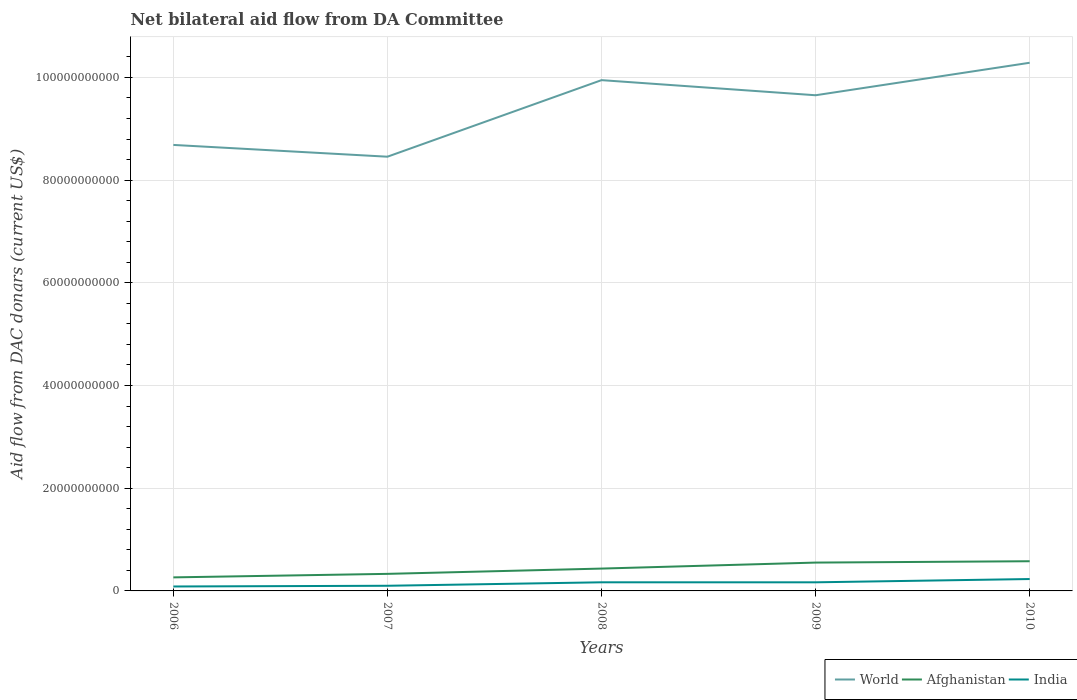Across all years, what is the maximum aid flow in in World?
Keep it short and to the point. 8.46e+1. What is the total aid flow in in World in the graph?
Your response must be concise. 2.29e+09. What is the difference between the highest and the second highest aid flow in in World?
Provide a short and direct response. 1.83e+1. What is the difference between the highest and the lowest aid flow in in World?
Your response must be concise. 3. Is the aid flow in in India strictly greater than the aid flow in in World over the years?
Your response must be concise. Yes. How many lines are there?
Give a very brief answer. 3. How many years are there in the graph?
Offer a terse response. 5. What is the difference between two consecutive major ticks on the Y-axis?
Provide a short and direct response. 2.00e+1. Does the graph contain any zero values?
Your response must be concise. No. Does the graph contain grids?
Provide a succinct answer. Yes. Where does the legend appear in the graph?
Offer a terse response. Bottom right. How many legend labels are there?
Offer a very short reply. 3. What is the title of the graph?
Make the answer very short. Net bilateral aid flow from DA Committee. What is the label or title of the Y-axis?
Your response must be concise. Aid flow from DAC donars (current US$). What is the Aid flow from DAC donars (current US$) in World in 2006?
Offer a terse response. 8.68e+1. What is the Aid flow from DAC donars (current US$) in Afghanistan in 2006?
Offer a very short reply. 2.64e+09. What is the Aid flow from DAC donars (current US$) in India in 2006?
Ensure brevity in your answer.  8.64e+08. What is the Aid flow from DAC donars (current US$) of World in 2007?
Offer a terse response. 8.46e+1. What is the Aid flow from DAC donars (current US$) in Afghanistan in 2007?
Offer a terse response. 3.32e+09. What is the Aid flow from DAC donars (current US$) of India in 2007?
Offer a terse response. 1.00e+09. What is the Aid flow from DAC donars (current US$) in World in 2008?
Your answer should be very brief. 9.95e+1. What is the Aid flow from DAC donars (current US$) of Afghanistan in 2008?
Make the answer very short. 4.35e+09. What is the Aid flow from DAC donars (current US$) in India in 2008?
Offer a terse response. 1.68e+09. What is the Aid flow from DAC donars (current US$) in World in 2009?
Provide a short and direct response. 9.65e+1. What is the Aid flow from DAC donars (current US$) of Afghanistan in 2009?
Your answer should be compact. 5.52e+09. What is the Aid flow from DAC donars (current US$) in India in 2009?
Give a very brief answer. 1.68e+09. What is the Aid flow from DAC donars (current US$) in World in 2010?
Keep it short and to the point. 1.03e+11. What is the Aid flow from DAC donars (current US$) of Afghanistan in 2010?
Give a very brief answer. 5.78e+09. What is the Aid flow from DAC donars (current US$) of India in 2010?
Your answer should be very brief. 2.31e+09. Across all years, what is the maximum Aid flow from DAC donars (current US$) of World?
Provide a succinct answer. 1.03e+11. Across all years, what is the maximum Aid flow from DAC donars (current US$) in Afghanistan?
Your answer should be compact. 5.78e+09. Across all years, what is the maximum Aid flow from DAC donars (current US$) in India?
Ensure brevity in your answer.  2.31e+09. Across all years, what is the minimum Aid flow from DAC donars (current US$) in World?
Offer a very short reply. 8.46e+1. Across all years, what is the minimum Aid flow from DAC donars (current US$) of Afghanistan?
Give a very brief answer. 2.64e+09. Across all years, what is the minimum Aid flow from DAC donars (current US$) in India?
Offer a terse response. 8.64e+08. What is the total Aid flow from DAC donars (current US$) in World in the graph?
Your answer should be very brief. 4.70e+11. What is the total Aid flow from DAC donars (current US$) of Afghanistan in the graph?
Offer a terse response. 2.16e+1. What is the total Aid flow from DAC donars (current US$) of India in the graph?
Provide a short and direct response. 7.54e+09. What is the difference between the Aid flow from DAC donars (current US$) of World in 2006 and that in 2007?
Keep it short and to the point. 2.29e+09. What is the difference between the Aid flow from DAC donars (current US$) in Afghanistan in 2006 and that in 2007?
Provide a succinct answer. -6.83e+08. What is the difference between the Aid flow from DAC donars (current US$) in India in 2006 and that in 2007?
Your answer should be compact. -1.40e+08. What is the difference between the Aid flow from DAC donars (current US$) in World in 2006 and that in 2008?
Keep it short and to the point. -1.26e+1. What is the difference between the Aid flow from DAC donars (current US$) of Afghanistan in 2006 and that in 2008?
Provide a short and direct response. -1.71e+09. What is the difference between the Aid flow from DAC donars (current US$) in India in 2006 and that in 2008?
Ensure brevity in your answer.  -8.15e+08. What is the difference between the Aid flow from DAC donars (current US$) of World in 2006 and that in 2009?
Your answer should be very brief. -9.67e+09. What is the difference between the Aid flow from DAC donars (current US$) in Afghanistan in 2006 and that in 2009?
Your response must be concise. -2.88e+09. What is the difference between the Aid flow from DAC donars (current US$) in India in 2006 and that in 2009?
Provide a succinct answer. -8.13e+08. What is the difference between the Aid flow from DAC donars (current US$) of World in 2006 and that in 2010?
Offer a very short reply. -1.60e+1. What is the difference between the Aid flow from DAC donars (current US$) of Afghanistan in 2006 and that in 2010?
Offer a terse response. -3.14e+09. What is the difference between the Aid flow from DAC donars (current US$) in India in 2006 and that in 2010?
Provide a short and direct response. -1.45e+09. What is the difference between the Aid flow from DAC donars (current US$) in World in 2007 and that in 2008?
Give a very brief answer. -1.49e+1. What is the difference between the Aid flow from DAC donars (current US$) of Afghanistan in 2007 and that in 2008?
Provide a short and direct response. -1.03e+09. What is the difference between the Aid flow from DAC donars (current US$) of India in 2007 and that in 2008?
Make the answer very short. -6.75e+08. What is the difference between the Aid flow from DAC donars (current US$) in World in 2007 and that in 2009?
Your answer should be very brief. -1.20e+1. What is the difference between the Aid flow from DAC donars (current US$) of Afghanistan in 2007 and that in 2009?
Your response must be concise. -2.20e+09. What is the difference between the Aid flow from DAC donars (current US$) of India in 2007 and that in 2009?
Ensure brevity in your answer.  -6.73e+08. What is the difference between the Aid flow from DAC donars (current US$) of World in 2007 and that in 2010?
Keep it short and to the point. -1.83e+1. What is the difference between the Aid flow from DAC donars (current US$) in Afghanistan in 2007 and that in 2010?
Give a very brief answer. -2.46e+09. What is the difference between the Aid flow from DAC donars (current US$) of India in 2007 and that in 2010?
Your response must be concise. -1.31e+09. What is the difference between the Aid flow from DAC donars (current US$) of World in 2008 and that in 2009?
Give a very brief answer. 2.94e+09. What is the difference between the Aid flow from DAC donars (current US$) in Afghanistan in 2008 and that in 2009?
Provide a succinct answer. -1.17e+09. What is the difference between the Aid flow from DAC donars (current US$) in India in 2008 and that in 2009?
Provide a short and direct response. 1.66e+06. What is the difference between the Aid flow from DAC donars (current US$) in World in 2008 and that in 2010?
Offer a very short reply. -3.38e+09. What is the difference between the Aid flow from DAC donars (current US$) of Afghanistan in 2008 and that in 2010?
Ensure brevity in your answer.  -1.43e+09. What is the difference between the Aid flow from DAC donars (current US$) of India in 2008 and that in 2010?
Ensure brevity in your answer.  -6.35e+08. What is the difference between the Aid flow from DAC donars (current US$) in World in 2009 and that in 2010?
Offer a terse response. -6.33e+09. What is the difference between the Aid flow from DAC donars (current US$) in Afghanistan in 2009 and that in 2010?
Provide a succinct answer. -2.60e+08. What is the difference between the Aid flow from DAC donars (current US$) of India in 2009 and that in 2010?
Make the answer very short. -6.37e+08. What is the difference between the Aid flow from DAC donars (current US$) of World in 2006 and the Aid flow from DAC donars (current US$) of Afghanistan in 2007?
Your response must be concise. 8.35e+1. What is the difference between the Aid flow from DAC donars (current US$) of World in 2006 and the Aid flow from DAC donars (current US$) of India in 2007?
Offer a very short reply. 8.58e+1. What is the difference between the Aid flow from DAC donars (current US$) in Afghanistan in 2006 and the Aid flow from DAC donars (current US$) in India in 2007?
Give a very brief answer. 1.63e+09. What is the difference between the Aid flow from DAC donars (current US$) of World in 2006 and the Aid flow from DAC donars (current US$) of Afghanistan in 2008?
Keep it short and to the point. 8.25e+1. What is the difference between the Aid flow from DAC donars (current US$) in World in 2006 and the Aid flow from DAC donars (current US$) in India in 2008?
Your answer should be compact. 8.52e+1. What is the difference between the Aid flow from DAC donars (current US$) of Afghanistan in 2006 and the Aid flow from DAC donars (current US$) of India in 2008?
Give a very brief answer. 9.60e+08. What is the difference between the Aid flow from DAC donars (current US$) in World in 2006 and the Aid flow from DAC donars (current US$) in Afghanistan in 2009?
Your answer should be compact. 8.13e+1. What is the difference between the Aid flow from DAC donars (current US$) of World in 2006 and the Aid flow from DAC donars (current US$) of India in 2009?
Provide a short and direct response. 8.52e+1. What is the difference between the Aid flow from DAC donars (current US$) of Afghanistan in 2006 and the Aid flow from DAC donars (current US$) of India in 2009?
Offer a very short reply. 9.61e+08. What is the difference between the Aid flow from DAC donars (current US$) of World in 2006 and the Aid flow from DAC donars (current US$) of Afghanistan in 2010?
Your answer should be compact. 8.11e+1. What is the difference between the Aid flow from DAC donars (current US$) in World in 2006 and the Aid flow from DAC donars (current US$) in India in 2010?
Provide a short and direct response. 8.45e+1. What is the difference between the Aid flow from DAC donars (current US$) in Afghanistan in 2006 and the Aid flow from DAC donars (current US$) in India in 2010?
Make the answer very short. 3.24e+08. What is the difference between the Aid flow from DAC donars (current US$) in World in 2007 and the Aid flow from DAC donars (current US$) in Afghanistan in 2008?
Make the answer very short. 8.02e+1. What is the difference between the Aid flow from DAC donars (current US$) in World in 2007 and the Aid flow from DAC donars (current US$) in India in 2008?
Provide a short and direct response. 8.29e+1. What is the difference between the Aid flow from DAC donars (current US$) of Afghanistan in 2007 and the Aid flow from DAC donars (current US$) of India in 2008?
Give a very brief answer. 1.64e+09. What is the difference between the Aid flow from DAC donars (current US$) of World in 2007 and the Aid flow from DAC donars (current US$) of Afghanistan in 2009?
Offer a very short reply. 7.90e+1. What is the difference between the Aid flow from DAC donars (current US$) in World in 2007 and the Aid flow from DAC donars (current US$) in India in 2009?
Offer a very short reply. 8.29e+1. What is the difference between the Aid flow from DAC donars (current US$) of Afghanistan in 2007 and the Aid flow from DAC donars (current US$) of India in 2009?
Your answer should be compact. 1.64e+09. What is the difference between the Aid flow from DAC donars (current US$) of World in 2007 and the Aid flow from DAC donars (current US$) of Afghanistan in 2010?
Your answer should be compact. 7.88e+1. What is the difference between the Aid flow from DAC donars (current US$) in World in 2007 and the Aid flow from DAC donars (current US$) in India in 2010?
Ensure brevity in your answer.  8.22e+1. What is the difference between the Aid flow from DAC donars (current US$) of Afghanistan in 2007 and the Aid flow from DAC donars (current US$) of India in 2010?
Offer a very short reply. 1.01e+09. What is the difference between the Aid flow from DAC donars (current US$) of World in 2008 and the Aid flow from DAC donars (current US$) of Afghanistan in 2009?
Provide a succinct answer. 9.39e+1. What is the difference between the Aid flow from DAC donars (current US$) of World in 2008 and the Aid flow from DAC donars (current US$) of India in 2009?
Your answer should be compact. 9.78e+1. What is the difference between the Aid flow from DAC donars (current US$) in Afghanistan in 2008 and the Aid flow from DAC donars (current US$) in India in 2009?
Offer a terse response. 2.67e+09. What is the difference between the Aid flow from DAC donars (current US$) in World in 2008 and the Aid flow from DAC donars (current US$) in Afghanistan in 2010?
Keep it short and to the point. 9.37e+1. What is the difference between the Aid flow from DAC donars (current US$) in World in 2008 and the Aid flow from DAC donars (current US$) in India in 2010?
Provide a succinct answer. 9.71e+1. What is the difference between the Aid flow from DAC donars (current US$) in Afghanistan in 2008 and the Aid flow from DAC donars (current US$) in India in 2010?
Keep it short and to the point. 2.04e+09. What is the difference between the Aid flow from DAC donars (current US$) of World in 2009 and the Aid flow from DAC donars (current US$) of Afghanistan in 2010?
Keep it short and to the point. 9.07e+1. What is the difference between the Aid flow from DAC donars (current US$) in World in 2009 and the Aid flow from DAC donars (current US$) in India in 2010?
Keep it short and to the point. 9.42e+1. What is the difference between the Aid flow from DAC donars (current US$) of Afghanistan in 2009 and the Aid flow from DAC donars (current US$) of India in 2010?
Ensure brevity in your answer.  3.21e+09. What is the average Aid flow from DAC donars (current US$) of World per year?
Provide a short and direct response. 9.40e+1. What is the average Aid flow from DAC donars (current US$) of Afghanistan per year?
Your answer should be compact. 4.32e+09. What is the average Aid flow from DAC donars (current US$) of India per year?
Provide a succinct answer. 1.51e+09. In the year 2006, what is the difference between the Aid flow from DAC donars (current US$) of World and Aid flow from DAC donars (current US$) of Afghanistan?
Offer a very short reply. 8.42e+1. In the year 2006, what is the difference between the Aid flow from DAC donars (current US$) in World and Aid flow from DAC donars (current US$) in India?
Your answer should be compact. 8.60e+1. In the year 2006, what is the difference between the Aid flow from DAC donars (current US$) in Afghanistan and Aid flow from DAC donars (current US$) in India?
Ensure brevity in your answer.  1.77e+09. In the year 2007, what is the difference between the Aid flow from DAC donars (current US$) of World and Aid flow from DAC donars (current US$) of Afghanistan?
Your answer should be very brief. 8.12e+1. In the year 2007, what is the difference between the Aid flow from DAC donars (current US$) in World and Aid flow from DAC donars (current US$) in India?
Provide a short and direct response. 8.36e+1. In the year 2007, what is the difference between the Aid flow from DAC donars (current US$) of Afghanistan and Aid flow from DAC donars (current US$) of India?
Give a very brief answer. 2.32e+09. In the year 2008, what is the difference between the Aid flow from DAC donars (current US$) of World and Aid flow from DAC donars (current US$) of Afghanistan?
Give a very brief answer. 9.51e+1. In the year 2008, what is the difference between the Aid flow from DAC donars (current US$) in World and Aid flow from DAC donars (current US$) in India?
Your answer should be very brief. 9.78e+1. In the year 2008, what is the difference between the Aid flow from DAC donars (current US$) in Afghanistan and Aid flow from DAC donars (current US$) in India?
Ensure brevity in your answer.  2.67e+09. In the year 2009, what is the difference between the Aid flow from DAC donars (current US$) in World and Aid flow from DAC donars (current US$) in Afghanistan?
Ensure brevity in your answer.  9.10e+1. In the year 2009, what is the difference between the Aid flow from DAC donars (current US$) of World and Aid flow from DAC donars (current US$) of India?
Provide a succinct answer. 9.48e+1. In the year 2009, what is the difference between the Aid flow from DAC donars (current US$) of Afghanistan and Aid flow from DAC donars (current US$) of India?
Give a very brief answer. 3.84e+09. In the year 2010, what is the difference between the Aid flow from DAC donars (current US$) in World and Aid flow from DAC donars (current US$) in Afghanistan?
Give a very brief answer. 9.71e+1. In the year 2010, what is the difference between the Aid flow from DAC donars (current US$) of World and Aid flow from DAC donars (current US$) of India?
Your answer should be very brief. 1.01e+11. In the year 2010, what is the difference between the Aid flow from DAC donars (current US$) of Afghanistan and Aid flow from DAC donars (current US$) of India?
Your response must be concise. 3.47e+09. What is the ratio of the Aid flow from DAC donars (current US$) in World in 2006 to that in 2007?
Offer a very short reply. 1.03. What is the ratio of the Aid flow from DAC donars (current US$) in Afghanistan in 2006 to that in 2007?
Keep it short and to the point. 0.79. What is the ratio of the Aid flow from DAC donars (current US$) of India in 2006 to that in 2007?
Make the answer very short. 0.86. What is the ratio of the Aid flow from DAC donars (current US$) of World in 2006 to that in 2008?
Offer a very short reply. 0.87. What is the ratio of the Aid flow from DAC donars (current US$) in Afghanistan in 2006 to that in 2008?
Your answer should be very brief. 0.61. What is the ratio of the Aid flow from DAC donars (current US$) in India in 2006 to that in 2008?
Your answer should be very brief. 0.51. What is the ratio of the Aid flow from DAC donars (current US$) of World in 2006 to that in 2009?
Offer a terse response. 0.9. What is the ratio of the Aid flow from DAC donars (current US$) in Afghanistan in 2006 to that in 2009?
Keep it short and to the point. 0.48. What is the ratio of the Aid flow from DAC donars (current US$) of India in 2006 to that in 2009?
Keep it short and to the point. 0.52. What is the ratio of the Aid flow from DAC donars (current US$) in World in 2006 to that in 2010?
Offer a very short reply. 0.84. What is the ratio of the Aid flow from DAC donars (current US$) of Afghanistan in 2006 to that in 2010?
Provide a succinct answer. 0.46. What is the ratio of the Aid flow from DAC donars (current US$) in India in 2006 to that in 2010?
Your answer should be compact. 0.37. What is the ratio of the Aid flow from DAC donars (current US$) of World in 2007 to that in 2008?
Your response must be concise. 0.85. What is the ratio of the Aid flow from DAC donars (current US$) of Afghanistan in 2007 to that in 2008?
Your answer should be compact. 0.76. What is the ratio of the Aid flow from DAC donars (current US$) in India in 2007 to that in 2008?
Provide a succinct answer. 0.6. What is the ratio of the Aid flow from DAC donars (current US$) of World in 2007 to that in 2009?
Provide a succinct answer. 0.88. What is the ratio of the Aid flow from DAC donars (current US$) in Afghanistan in 2007 to that in 2009?
Keep it short and to the point. 0.6. What is the ratio of the Aid flow from DAC donars (current US$) of India in 2007 to that in 2009?
Provide a succinct answer. 0.6. What is the ratio of the Aid flow from DAC donars (current US$) in World in 2007 to that in 2010?
Give a very brief answer. 0.82. What is the ratio of the Aid flow from DAC donars (current US$) in Afghanistan in 2007 to that in 2010?
Keep it short and to the point. 0.57. What is the ratio of the Aid flow from DAC donars (current US$) in India in 2007 to that in 2010?
Give a very brief answer. 0.43. What is the ratio of the Aid flow from DAC donars (current US$) of World in 2008 to that in 2009?
Your answer should be compact. 1.03. What is the ratio of the Aid flow from DAC donars (current US$) of Afghanistan in 2008 to that in 2009?
Offer a terse response. 0.79. What is the ratio of the Aid flow from DAC donars (current US$) in India in 2008 to that in 2009?
Ensure brevity in your answer.  1. What is the ratio of the Aid flow from DAC donars (current US$) of World in 2008 to that in 2010?
Your answer should be compact. 0.97. What is the ratio of the Aid flow from DAC donars (current US$) in Afghanistan in 2008 to that in 2010?
Keep it short and to the point. 0.75. What is the ratio of the Aid flow from DAC donars (current US$) of India in 2008 to that in 2010?
Offer a very short reply. 0.73. What is the ratio of the Aid flow from DAC donars (current US$) of World in 2009 to that in 2010?
Offer a terse response. 0.94. What is the ratio of the Aid flow from DAC donars (current US$) in Afghanistan in 2009 to that in 2010?
Ensure brevity in your answer.  0.95. What is the ratio of the Aid flow from DAC donars (current US$) in India in 2009 to that in 2010?
Provide a succinct answer. 0.72. What is the difference between the highest and the second highest Aid flow from DAC donars (current US$) of World?
Provide a succinct answer. 3.38e+09. What is the difference between the highest and the second highest Aid flow from DAC donars (current US$) of Afghanistan?
Your answer should be compact. 2.60e+08. What is the difference between the highest and the second highest Aid flow from DAC donars (current US$) of India?
Offer a terse response. 6.35e+08. What is the difference between the highest and the lowest Aid flow from DAC donars (current US$) of World?
Your response must be concise. 1.83e+1. What is the difference between the highest and the lowest Aid flow from DAC donars (current US$) of Afghanistan?
Your answer should be compact. 3.14e+09. What is the difference between the highest and the lowest Aid flow from DAC donars (current US$) in India?
Keep it short and to the point. 1.45e+09. 